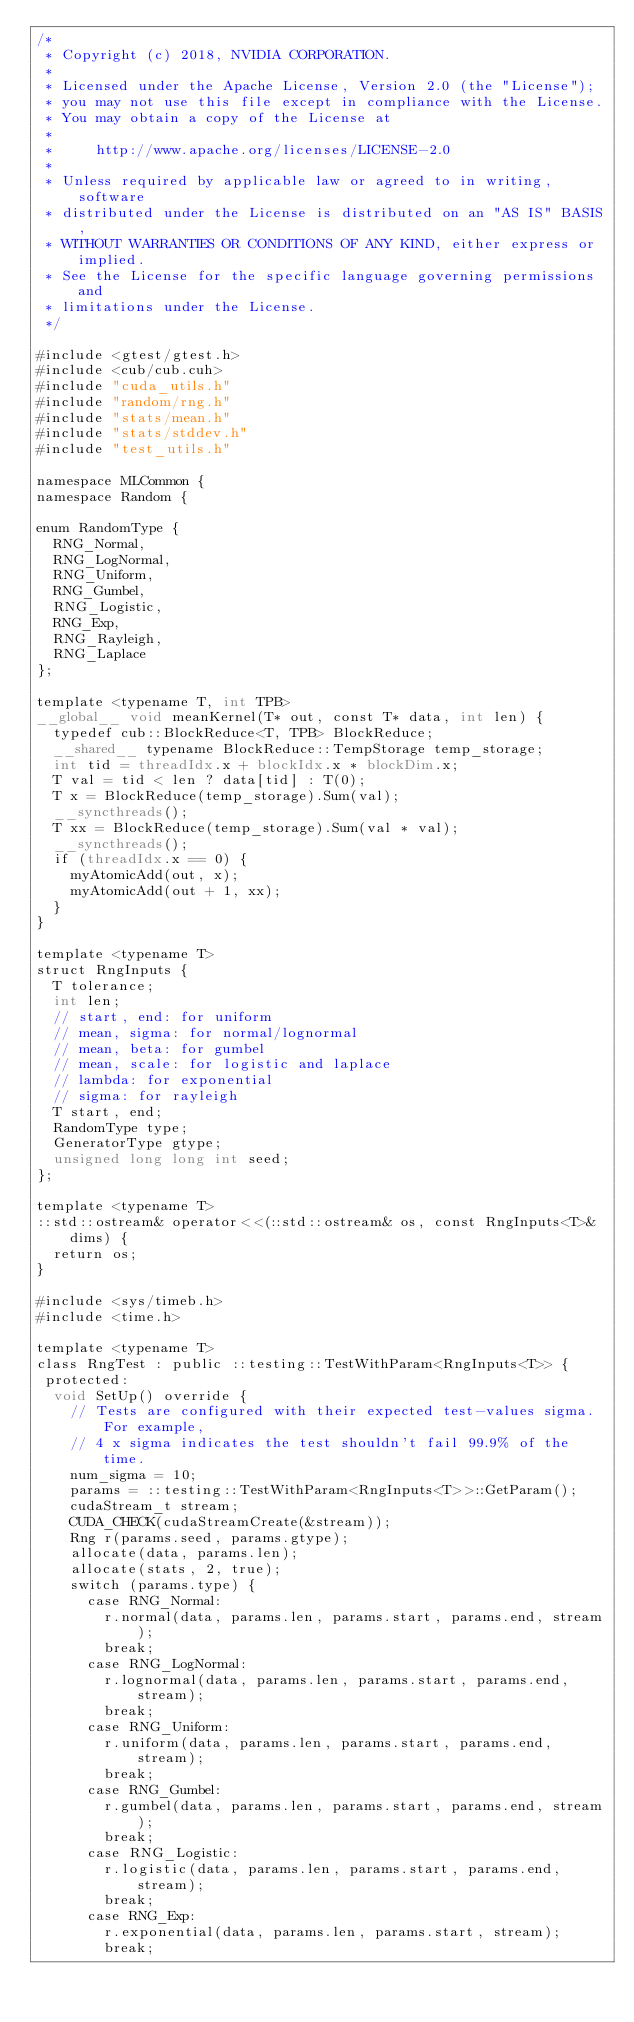<code> <loc_0><loc_0><loc_500><loc_500><_Cuda_>/*
 * Copyright (c) 2018, NVIDIA CORPORATION.
 *
 * Licensed under the Apache License, Version 2.0 (the "License");
 * you may not use this file except in compliance with the License.
 * You may obtain a copy of the License at
 *
 *     http://www.apache.org/licenses/LICENSE-2.0
 *
 * Unless required by applicable law or agreed to in writing, software
 * distributed under the License is distributed on an "AS IS" BASIS,
 * WITHOUT WARRANTIES OR CONDITIONS OF ANY KIND, either express or implied.
 * See the License for the specific language governing permissions and
 * limitations under the License.
 */

#include <gtest/gtest.h>
#include <cub/cub.cuh>
#include "cuda_utils.h"
#include "random/rng.h"
#include "stats/mean.h"
#include "stats/stddev.h"
#include "test_utils.h"

namespace MLCommon {
namespace Random {

enum RandomType {
  RNG_Normal,
  RNG_LogNormal,
  RNG_Uniform,
  RNG_Gumbel,
  RNG_Logistic,
  RNG_Exp,
  RNG_Rayleigh,
  RNG_Laplace
};

template <typename T, int TPB>
__global__ void meanKernel(T* out, const T* data, int len) {
  typedef cub::BlockReduce<T, TPB> BlockReduce;
  __shared__ typename BlockReduce::TempStorage temp_storage;
  int tid = threadIdx.x + blockIdx.x * blockDim.x;
  T val = tid < len ? data[tid] : T(0);
  T x = BlockReduce(temp_storage).Sum(val);
  __syncthreads();
  T xx = BlockReduce(temp_storage).Sum(val * val);
  __syncthreads();
  if (threadIdx.x == 0) {
    myAtomicAdd(out, x);
    myAtomicAdd(out + 1, xx);
  }
}

template <typename T>
struct RngInputs {
  T tolerance;
  int len;
  // start, end: for uniform
  // mean, sigma: for normal/lognormal
  // mean, beta: for gumbel
  // mean, scale: for logistic and laplace
  // lambda: for exponential
  // sigma: for rayleigh
  T start, end;
  RandomType type;
  GeneratorType gtype;
  unsigned long long int seed;
};

template <typename T>
::std::ostream& operator<<(::std::ostream& os, const RngInputs<T>& dims) {
  return os;
}

#include <sys/timeb.h>
#include <time.h>

template <typename T>
class RngTest : public ::testing::TestWithParam<RngInputs<T>> {
 protected:
  void SetUp() override {
    // Tests are configured with their expected test-values sigma. For example,
    // 4 x sigma indicates the test shouldn't fail 99.9% of the time.
    num_sigma = 10;
    params = ::testing::TestWithParam<RngInputs<T>>::GetParam();
    cudaStream_t stream;
    CUDA_CHECK(cudaStreamCreate(&stream));
    Rng r(params.seed, params.gtype);
    allocate(data, params.len);
    allocate(stats, 2, true);
    switch (params.type) {
      case RNG_Normal:
        r.normal(data, params.len, params.start, params.end, stream);
        break;
      case RNG_LogNormal:
        r.lognormal(data, params.len, params.start, params.end, stream);
        break;
      case RNG_Uniform:
        r.uniform(data, params.len, params.start, params.end, stream);
        break;
      case RNG_Gumbel:
        r.gumbel(data, params.len, params.start, params.end, stream);
        break;
      case RNG_Logistic:
        r.logistic(data, params.len, params.start, params.end, stream);
        break;
      case RNG_Exp:
        r.exponential(data, params.len, params.start, stream);
        break;</code> 